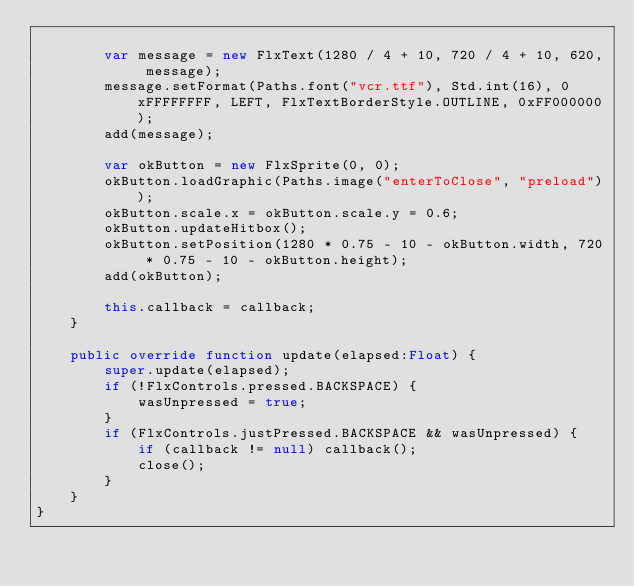Convert code to text. <code><loc_0><loc_0><loc_500><loc_500><_Haxe_>
        var message = new FlxText(1280 / 4 + 10, 720 / 4 + 10, 620, message);
		message.setFormat(Paths.font("vcr.ttf"), Std.int(16), 0xFFFFFFFF, LEFT, FlxTextBorderStyle.OUTLINE, 0xFF000000);
        add(message);

        var okButton = new FlxSprite(0, 0);
        okButton.loadGraphic(Paths.image("enterToClose", "preload"));
        okButton.scale.x = okButton.scale.y = 0.6;
        okButton.updateHitbox();
        okButton.setPosition(1280 * 0.75 - 10 - okButton.width, 720 * 0.75 - 10 - okButton.height);
        add(okButton);

        this.callback = callback;
    }

    public override function update(elapsed:Float) {
        super.update(elapsed);
        if (!FlxControls.pressed.BACKSPACE) {
            wasUnpressed = true;
        }
        if (FlxControls.justPressed.BACKSPACE && wasUnpressed) {
            if (callback != null) callback();
            close();
        }
    }
}</code> 